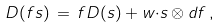<formula> <loc_0><loc_0><loc_500><loc_500>D ( f s ) \, = \, f D ( s ) + w { \cdot } s \otimes d f \, ,</formula> 